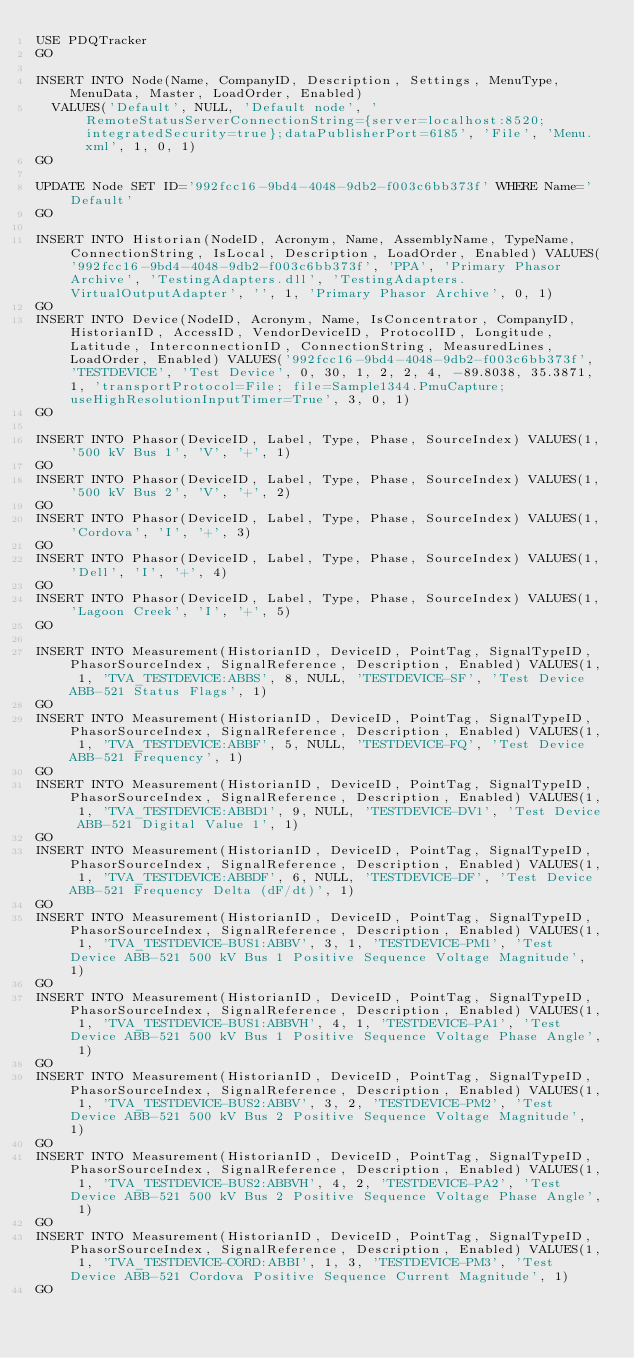<code> <loc_0><loc_0><loc_500><loc_500><_SQL_>USE PDQTracker
GO

INSERT INTO Node(Name, CompanyID, Description, Settings, MenuType, MenuData, Master, LoadOrder, Enabled) 
	VALUES('Default', NULL, 'Default node', 'RemoteStatusServerConnectionString={server=localhost:8520;integratedSecurity=true};dataPublisherPort=6185', 'File', 'Menu.xml', 1, 0, 1)
GO

UPDATE Node SET ID='992fcc16-9bd4-4048-9db2-f003c6bb373f' WHERE Name='Default'
GO

INSERT INTO Historian(NodeID, Acronym, Name, AssemblyName, TypeName, ConnectionString, IsLocal, Description, LoadOrder, Enabled) VALUES('992fcc16-9bd4-4048-9db2-f003c6bb373f', 'PPA', 'Primary Phasor Archive', 'TestingAdapters.dll', 'TestingAdapters.VirtualOutputAdapter', '', 1, 'Primary Phasor Archive', 0, 1)
GO
INSERT INTO Device(NodeID, Acronym, Name, IsConcentrator, CompanyID, HistorianID, AccessID, VendorDeviceID, ProtocolID, Longitude, Latitude, InterconnectionID, ConnectionString, MeasuredLines, LoadOrder, Enabled) VALUES('992fcc16-9bd4-4048-9db2-f003c6bb373f', 'TESTDEVICE', 'Test Device', 0, 30, 1, 2, 2, 4, -89.8038, 35.3871, 1, 'transportProtocol=File; file=Sample1344.PmuCapture; useHighResolutionInputTimer=True', 3, 0, 1)
GO

INSERT INTO Phasor(DeviceID, Label, Type, Phase, SourceIndex) VALUES(1, '500 kV Bus 1', 'V', '+', 1)
GO
INSERT INTO Phasor(DeviceID, Label, Type, Phase, SourceIndex) VALUES(1, '500 kV Bus 2', 'V', '+', 2)
GO
INSERT INTO Phasor(DeviceID, Label, Type, Phase, SourceIndex) VALUES(1, 'Cordova', 'I', '+', 3)
GO
INSERT INTO Phasor(DeviceID, Label, Type, Phase, SourceIndex) VALUES(1, 'Dell', 'I', '+', 4)
GO
INSERT INTO Phasor(DeviceID, Label, Type, Phase, SourceIndex) VALUES(1, 'Lagoon Creek', 'I', '+', 5)
GO

INSERT INTO Measurement(HistorianID, DeviceID, PointTag, SignalTypeID, PhasorSourceIndex, SignalReference, Description, Enabled) VALUES(1, 1, 'TVA_TESTDEVICE:ABBS', 8, NULL, 'TESTDEVICE-SF', 'Test Device ABB-521 Status Flags', 1)
GO
INSERT INTO Measurement(HistorianID, DeviceID, PointTag, SignalTypeID, PhasorSourceIndex, SignalReference, Description, Enabled) VALUES(1, 1, 'TVA_TESTDEVICE:ABBF', 5, NULL, 'TESTDEVICE-FQ', 'Test Device ABB-521 Frequency', 1)
GO
INSERT INTO Measurement(HistorianID, DeviceID, PointTag, SignalTypeID, PhasorSourceIndex, SignalReference, Description, Enabled) VALUES(1, 1, 'TVA_TESTDEVICE:ABBD1', 9, NULL, 'TESTDEVICE-DV1', 'Test Device ABB-521 Digital Value 1', 1)
GO
INSERT INTO Measurement(HistorianID, DeviceID, PointTag, SignalTypeID, PhasorSourceIndex, SignalReference, Description, Enabled) VALUES(1, 1, 'TVA_TESTDEVICE:ABBDF', 6, NULL, 'TESTDEVICE-DF', 'Test Device ABB-521 Frequency Delta (dF/dt)', 1)
GO
INSERT INTO Measurement(HistorianID, DeviceID, PointTag, SignalTypeID, PhasorSourceIndex, SignalReference, Description, Enabled) VALUES(1, 1, 'TVA_TESTDEVICE-BUS1:ABBV', 3, 1, 'TESTDEVICE-PM1', 'Test Device ABB-521 500 kV Bus 1 Positive Sequence Voltage Magnitude', 1)
GO
INSERT INTO Measurement(HistorianID, DeviceID, PointTag, SignalTypeID, PhasorSourceIndex, SignalReference, Description, Enabled) VALUES(1, 1, 'TVA_TESTDEVICE-BUS1:ABBVH', 4, 1, 'TESTDEVICE-PA1', 'Test Device ABB-521 500 kV Bus 1 Positive Sequence Voltage Phase Angle', 1)
GO
INSERT INTO Measurement(HistorianID, DeviceID, PointTag, SignalTypeID, PhasorSourceIndex, SignalReference, Description, Enabled) VALUES(1, 1, 'TVA_TESTDEVICE-BUS2:ABBV', 3, 2, 'TESTDEVICE-PM2', 'Test Device ABB-521 500 kV Bus 2 Positive Sequence Voltage Magnitude', 1)
GO
INSERT INTO Measurement(HistorianID, DeviceID, PointTag, SignalTypeID, PhasorSourceIndex, SignalReference, Description, Enabled) VALUES(1, 1, 'TVA_TESTDEVICE-BUS2:ABBVH', 4, 2, 'TESTDEVICE-PA2', 'Test Device ABB-521 500 kV Bus 2 Positive Sequence Voltage Phase Angle', 1)
GO
INSERT INTO Measurement(HistorianID, DeviceID, PointTag, SignalTypeID, PhasorSourceIndex, SignalReference, Description, Enabled) VALUES(1, 1, 'TVA_TESTDEVICE-CORD:ABBI', 1, 3, 'TESTDEVICE-PM3', 'Test Device ABB-521 Cordova Positive Sequence Current Magnitude', 1)
GO</code> 